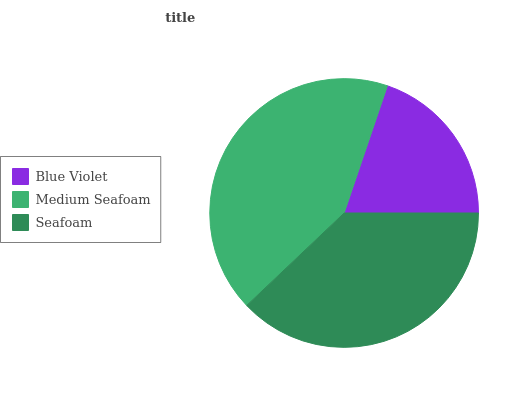Is Blue Violet the minimum?
Answer yes or no. Yes. Is Medium Seafoam the maximum?
Answer yes or no. Yes. Is Seafoam the minimum?
Answer yes or no. No. Is Seafoam the maximum?
Answer yes or no. No. Is Medium Seafoam greater than Seafoam?
Answer yes or no. Yes. Is Seafoam less than Medium Seafoam?
Answer yes or no. Yes. Is Seafoam greater than Medium Seafoam?
Answer yes or no. No. Is Medium Seafoam less than Seafoam?
Answer yes or no. No. Is Seafoam the high median?
Answer yes or no. Yes. Is Seafoam the low median?
Answer yes or no. Yes. Is Blue Violet the high median?
Answer yes or no. No. Is Blue Violet the low median?
Answer yes or no. No. 